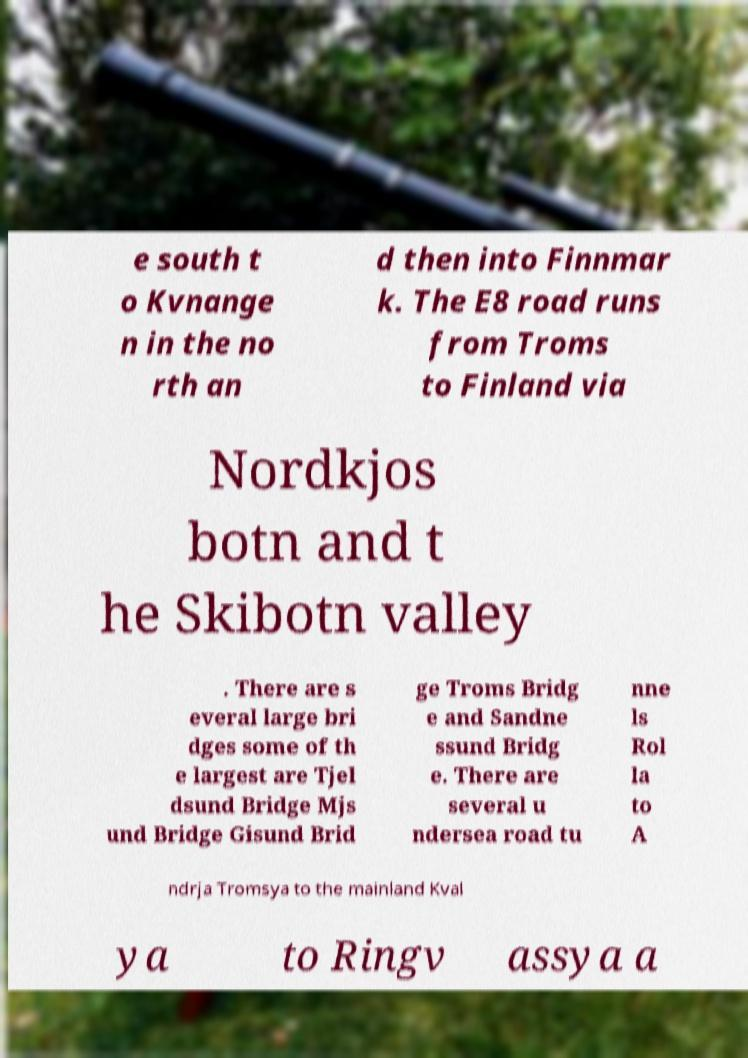Can you read and provide the text displayed in the image?This photo seems to have some interesting text. Can you extract and type it out for me? e south t o Kvnange n in the no rth an d then into Finnmar k. The E8 road runs from Troms to Finland via Nordkjos botn and t he Skibotn valley . There are s everal large bri dges some of th e largest are Tjel dsund Bridge Mjs und Bridge Gisund Brid ge Troms Bridg e and Sandne ssund Bridg e. There are several u ndersea road tu nne ls Rol la to A ndrja Tromsya to the mainland Kval ya to Ringv assya a 